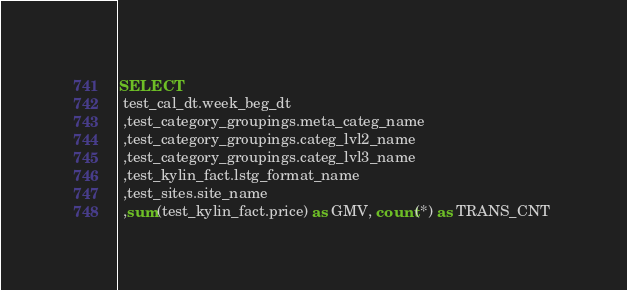Convert code to text. <code><loc_0><loc_0><loc_500><loc_500><_SQL_>SELECT 
 test_cal_dt.week_beg_dt 
 ,test_category_groupings.meta_categ_name 
 ,test_category_groupings.categ_lvl2_name 
 ,test_category_groupings.categ_lvl3_name 
 ,test_kylin_fact.lstg_format_name 
 ,test_sites.site_name 
 ,sum(test_kylin_fact.price) as GMV, count(*) as TRANS_CNT </code> 